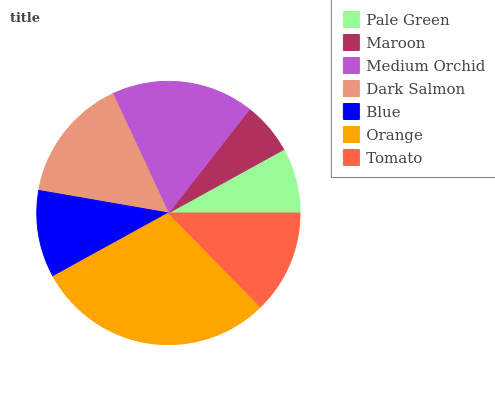Is Maroon the minimum?
Answer yes or no. Yes. Is Orange the maximum?
Answer yes or no. Yes. Is Medium Orchid the minimum?
Answer yes or no. No. Is Medium Orchid the maximum?
Answer yes or no. No. Is Medium Orchid greater than Maroon?
Answer yes or no. Yes. Is Maroon less than Medium Orchid?
Answer yes or no. Yes. Is Maroon greater than Medium Orchid?
Answer yes or no. No. Is Medium Orchid less than Maroon?
Answer yes or no. No. Is Tomato the high median?
Answer yes or no. Yes. Is Tomato the low median?
Answer yes or no. Yes. Is Orange the high median?
Answer yes or no. No. Is Maroon the low median?
Answer yes or no. No. 